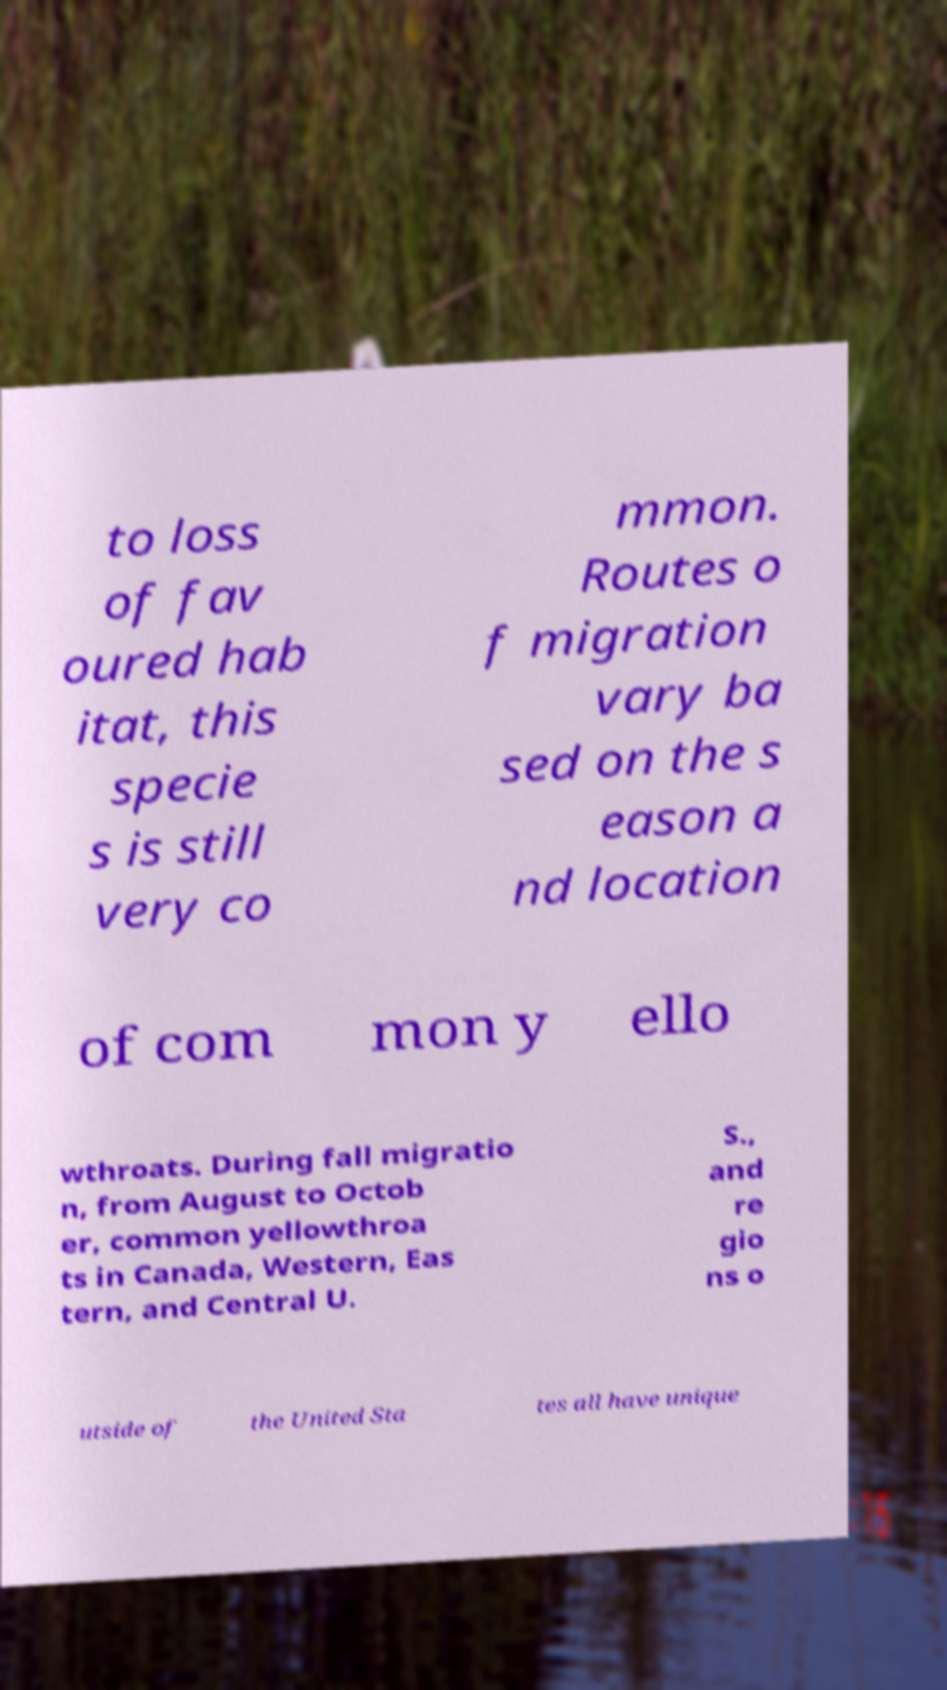For documentation purposes, I need the text within this image transcribed. Could you provide that? to loss of fav oured hab itat, this specie s is still very co mmon. Routes o f migration vary ba sed on the s eason a nd location of com mon y ello wthroats. During fall migratio n, from August to Octob er, common yellowthroa ts in Canada, Western, Eas tern, and Central U. S., and re gio ns o utside of the United Sta tes all have unique 